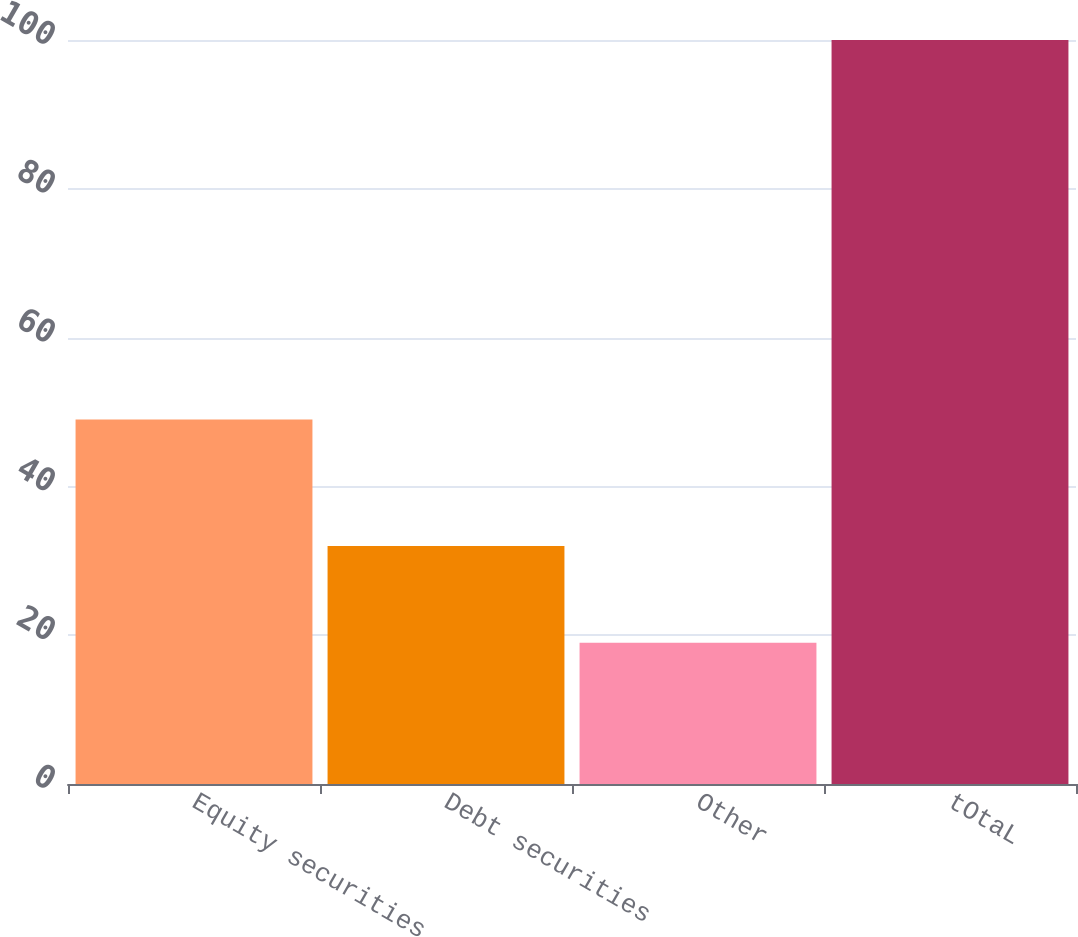<chart> <loc_0><loc_0><loc_500><loc_500><bar_chart><fcel>Equity securities<fcel>Debt securities<fcel>Other<fcel>tOtaL<nl><fcel>49<fcel>32<fcel>19<fcel>100<nl></chart> 